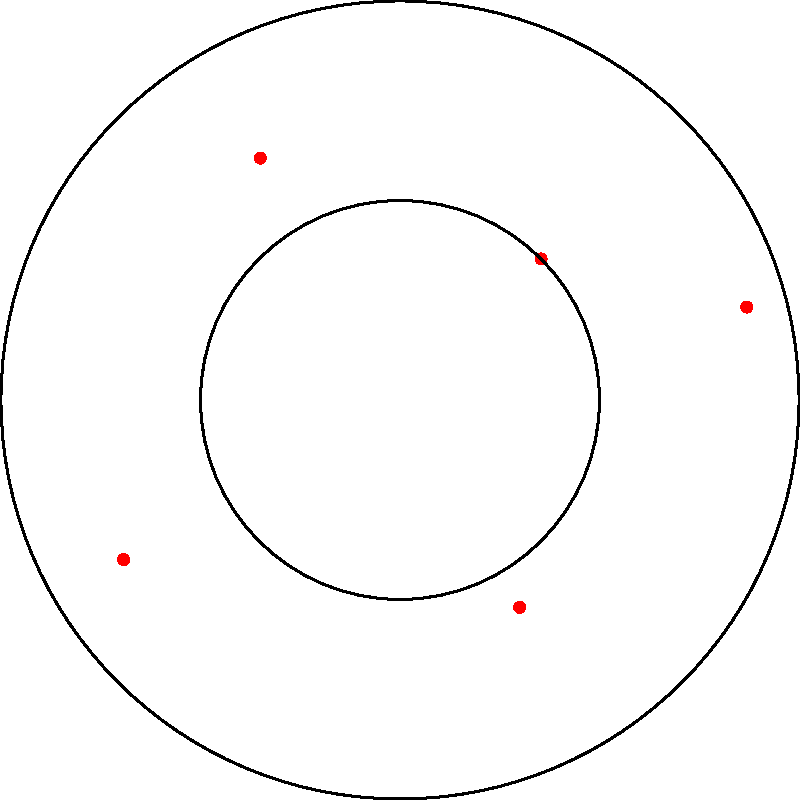Given the polar coordinate plot of customer locations for your disruptive eyewear startup, which quadrant shows the highest concentration of customers, and what strategic decision could you make based on this information? To answer this question, we need to analyze the polar coordinate plot step-by-step:

1. The plot is divided into four quadrants:
   - Quadrant I: 0° to 90° (Northeast)
   - Quadrant II: 90° to 180° (Southeast)
   - Quadrant III: 180° to 270° (Southwest)
   - Quadrant IV: 270° to 360° (Northwest)

2. Count the number of points in each quadrant:
   - Quadrant I: 2 points
   - Quadrant II: 1 point
   - Quadrant III: 1 point
   - Quadrant IV: 1 point

3. Quadrant I (Northeast) has the highest concentration of customers with 2 points.

4. Strategic decision based on this information:
   Given that the Northeast quadrant has the highest concentration of customers, a strategic decision could be to focus marketing efforts and expand operations in this region. This could involve:
   - Increasing targeted advertising in the Northeast
   - Opening physical pop-up stores or showrooms in this area
   - Tailoring product offerings to suit the preferences of customers in this region
   - Optimizing shipping and logistics for faster delivery to Northeast customers

By concentrating resources on the area with the highest customer density, the startup can maximize its return on investment and potentially accelerate market penetration in its strongest region.
Answer: Quadrant I (Northeast); focus marketing and expand operations in the Northeast region. 